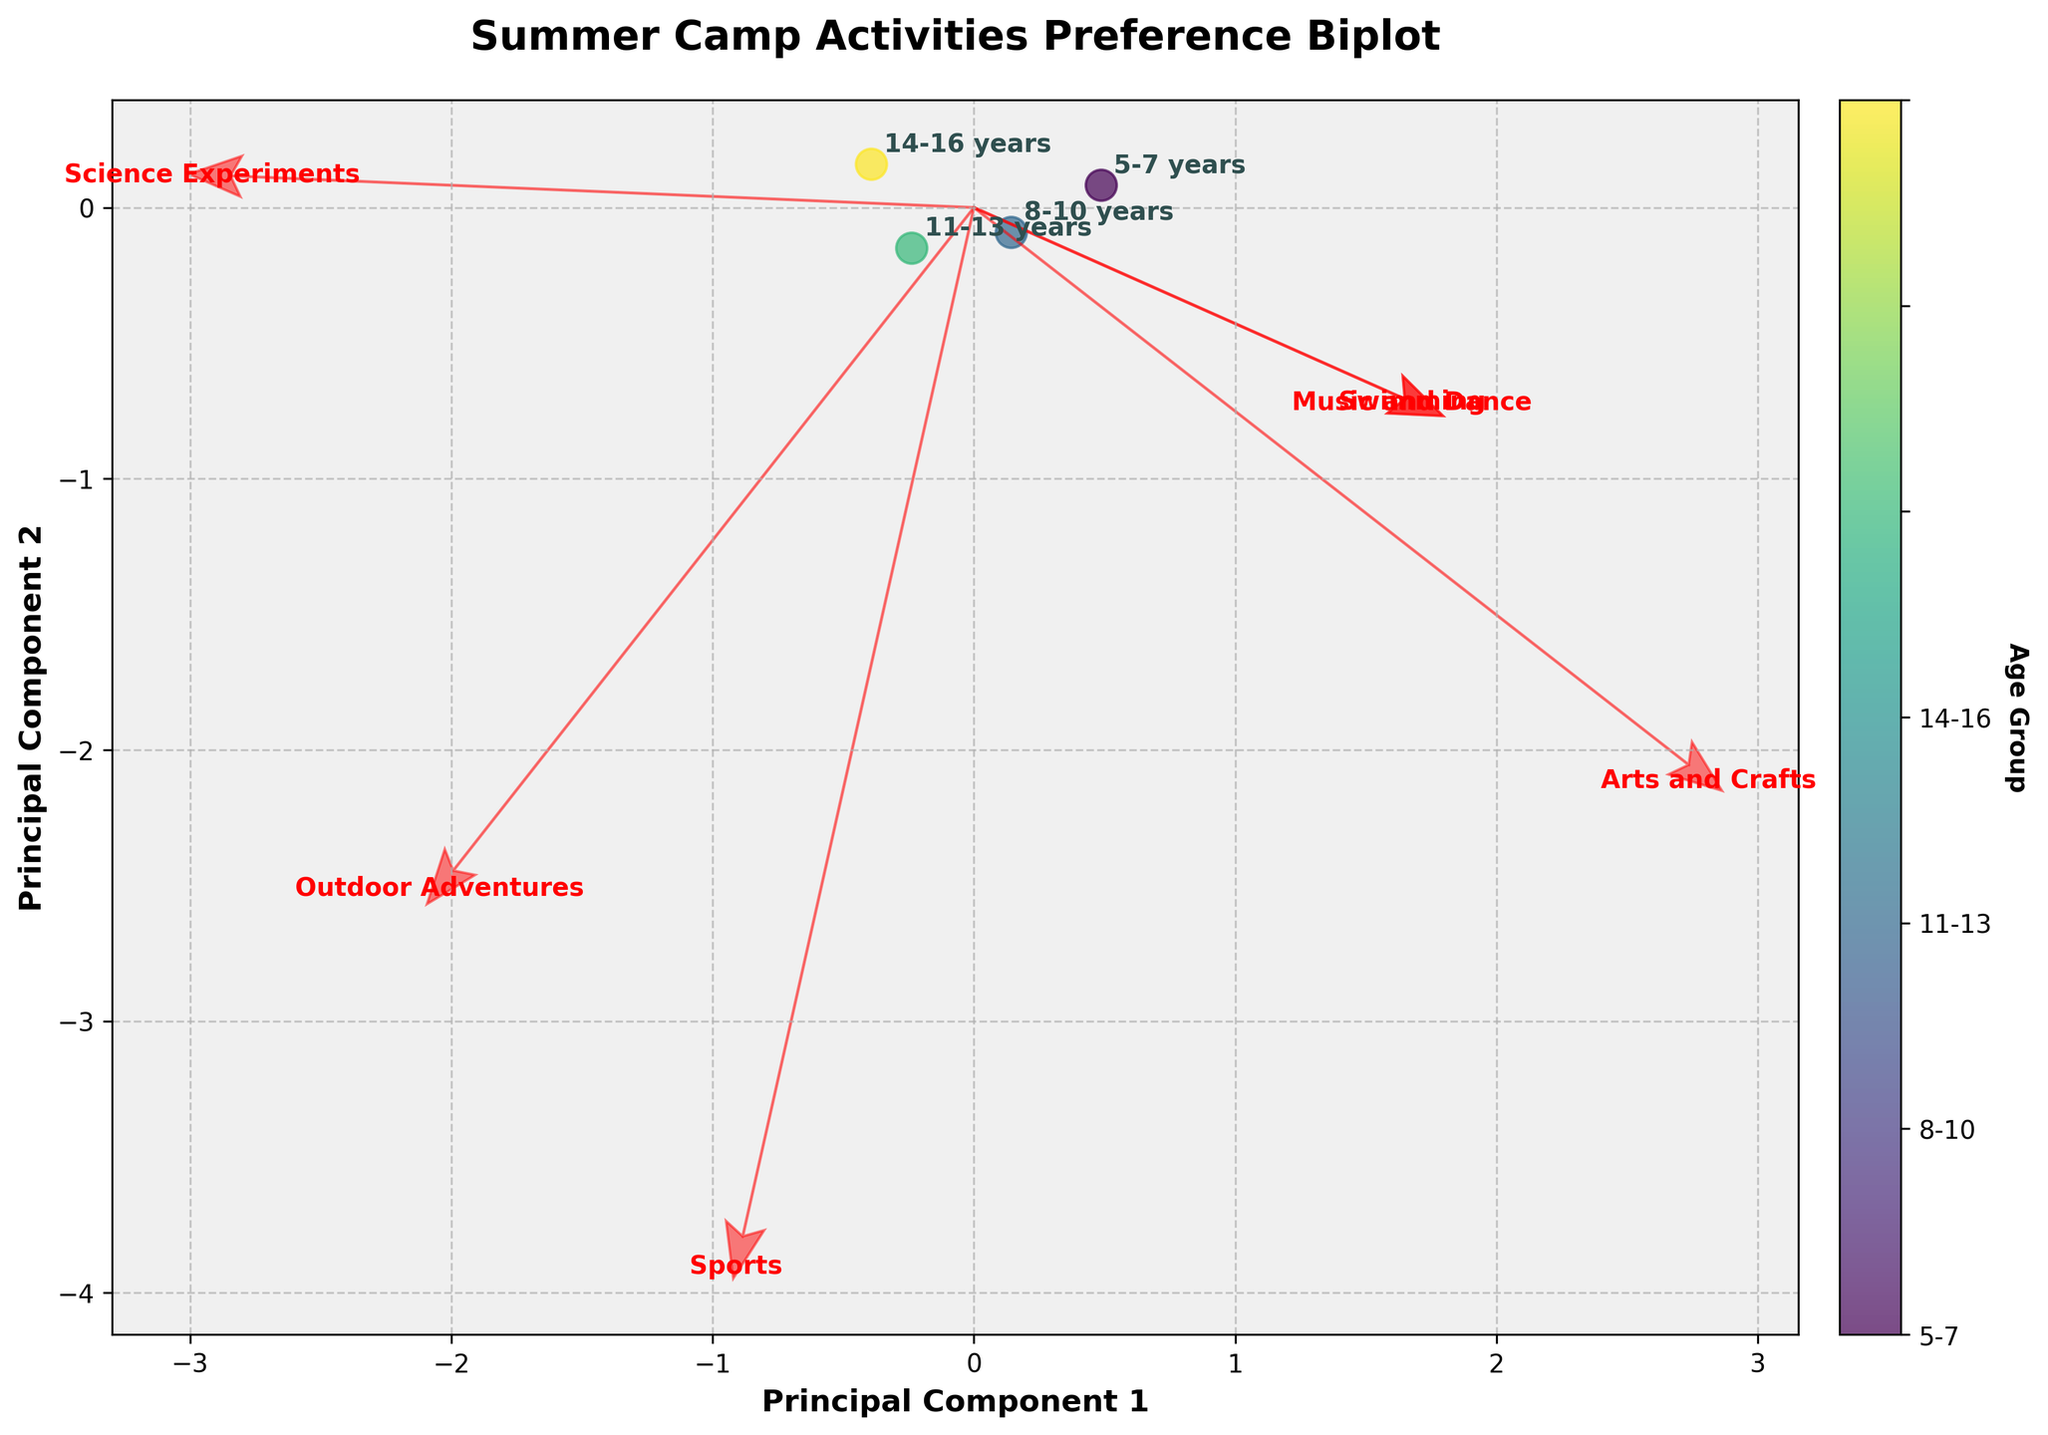What is the title of the plot? The title of the plot is placed prominently at the top and is formatted in bold to draw attention. It helps contextualize the figure for the viewer.
Answer: Summer Camp Activities Preference Biplot Which axis represents the Principal Component 1? The Principal Component 1 is marked on the horizontal axis (x-axis) as indicated by the label 'Principal Component 1'.
Answer: Horizontal axis How many age groups are represented in the plot? The plot contains four data points, each annotated with a respective age group. These are distinguished by colors and labels beside each data point.
Answer: 4 Which activity is positively correlated with both Principal Component 1 and Principal Component 2? The activity vectors start from the origin (0,0) and end in the positive directions of both components. By observing the arrows, 'Outdoor Adventures' vector points roughly equally in positive directions of PC1 and PC2.
Answer: Outdoor Adventures Which activity do children aged 5-7 years prefer the most? We find the data point labeled '5-7 years' and observe its position relative to the activities' vectors. The '5-7 years' point is closest to the 'Swimming' vector, indicating a high preference.
Answer: Swimming How does the preference for Arts and Crafts change with age? By examining the directions of the 'Arts and Crafts' vector in relation to the age group positions, younger age groups are closer to this vector, whereas older groups move away from it.
Answer: Decreases Which age group has the highest preference for Science Experiments? The 'Science Experiments' vector points in a direction closer to the '14-16 years' data point compared to other groups, indicating the highest preference as children grow older.
Answer: 14-16 years Is there any activity least preferred by children aged 14-16 years? The '14-16 years' point has the least positive projection onto the 'Arts and Crafts' vector, indicating a low preference.
Answer: Arts and Crafts What can be inferred about the relationship between age and preference for Music and Dance? The 'Music and Dance' vector points towards the 5-7 years and 8-10 years groups. As the dots representing age groups 11-13 and 14-16 are distanced from this vector, it suggests that younger children prefer this activity more.
Answer: Younger children prefer it more 